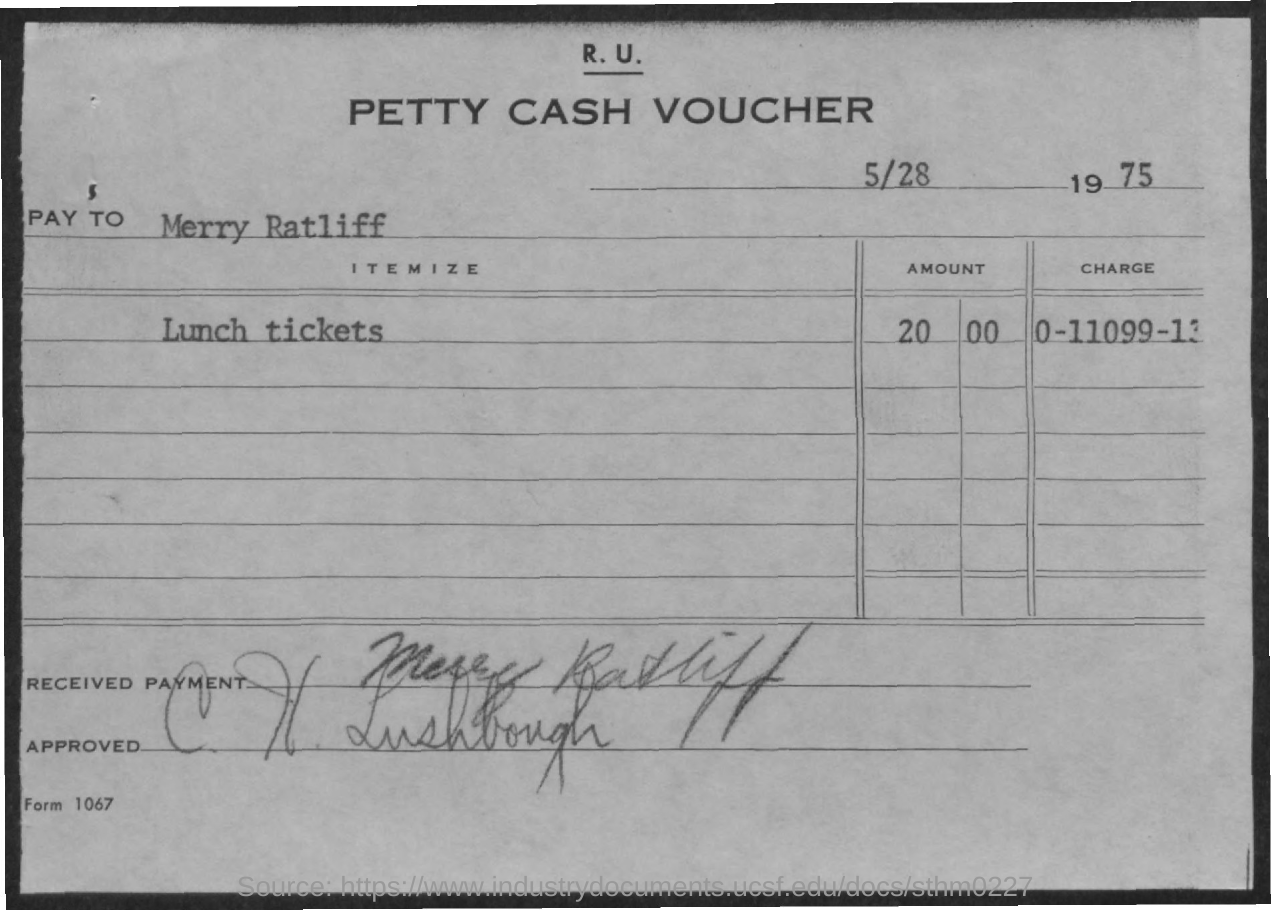What is the amount of lunch tickets mentioned in the voucher ?
Offer a very short reply. 20  00. What is the charge no. mentioned in the voucher ?
Keep it short and to the point. 0-11099-13. What is the name mentioned at pay to as mentioned in the given voucher ?
Provide a succinct answer. Merry ratliff. 